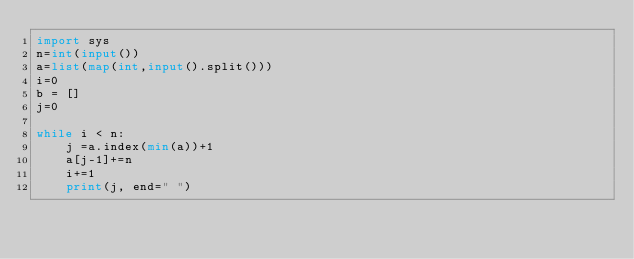<code> <loc_0><loc_0><loc_500><loc_500><_Python_>import sys
n=int(input())
a=list(map(int,input().split()))
i=0
b = []
j=0

while i < n:
    j =a.index(min(a))+1
    a[j-1]+=n
    i+=1
    print(j, end=" ")
</code> 